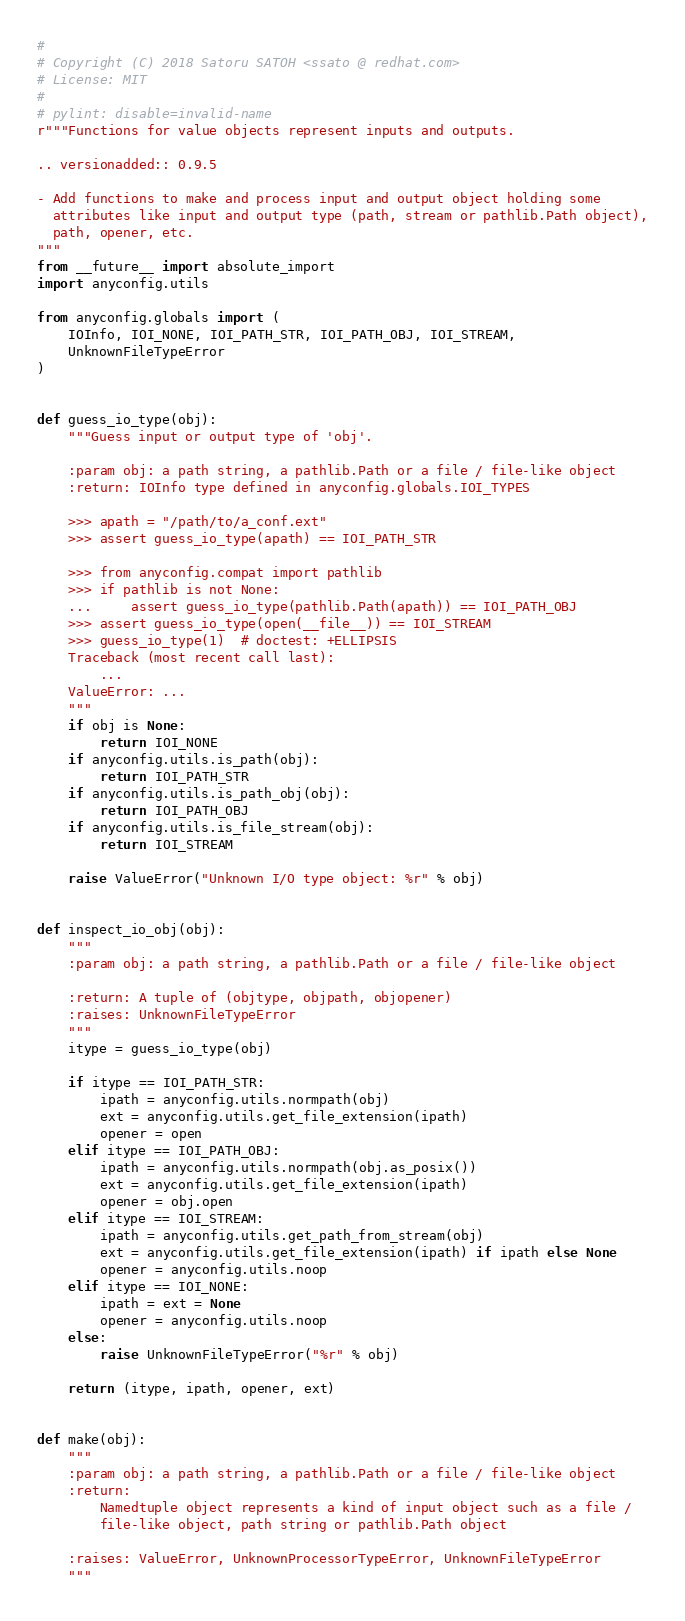<code> <loc_0><loc_0><loc_500><loc_500><_Python_>#
# Copyright (C) 2018 Satoru SATOH <ssato @ redhat.com>
# License: MIT
#
# pylint: disable=invalid-name
r"""Functions for value objects represent inputs and outputs.

.. versionadded:: 0.9.5

- Add functions to make and process input and output object holding some
  attributes like input and output type (path, stream or pathlib.Path object),
  path, opener, etc.
"""
from __future__ import absolute_import
import anyconfig.utils

from anyconfig.globals import (
    IOInfo, IOI_NONE, IOI_PATH_STR, IOI_PATH_OBJ, IOI_STREAM,
    UnknownFileTypeError
)


def guess_io_type(obj):
    """Guess input or output type of 'obj'.

    :param obj: a path string, a pathlib.Path or a file / file-like object
    :return: IOInfo type defined in anyconfig.globals.IOI_TYPES

    >>> apath = "/path/to/a_conf.ext"
    >>> assert guess_io_type(apath) == IOI_PATH_STR

    >>> from anyconfig.compat import pathlib
    >>> if pathlib is not None:
    ...     assert guess_io_type(pathlib.Path(apath)) == IOI_PATH_OBJ
    >>> assert guess_io_type(open(__file__)) == IOI_STREAM
    >>> guess_io_type(1)  # doctest: +ELLIPSIS
    Traceback (most recent call last):
        ...
    ValueError: ...
    """
    if obj is None:
        return IOI_NONE
    if anyconfig.utils.is_path(obj):
        return IOI_PATH_STR
    if anyconfig.utils.is_path_obj(obj):
        return IOI_PATH_OBJ
    if anyconfig.utils.is_file_stream(obj):
        return IOI_STREAM

    raise ValueError("Unknown I/O type object: %r" % obj)


def inspect_io_obj(obj):
    """
    :param obj: a path string, a pathlib.Path or a file / file-like object

    :return: A tuple of (objtype, objpath, objopener)
    :raises: UnknownFileTypeError
    """
    itype = guess_io_type(obj)

    if itype == IOI_PATH_STR:
        ipath = anyconfig.utils.normpath(obj)
        ext = anyconfig.utils.get_file_extension(ipath)
        opener = open
    elif itype == IOI_PATH_OBJ:
        ipath = anyconfig.utils.normpath(obj.as_posix())
        ext = anyconfig.utils.get_file_extension(ipath)
        opener = obj.open
    elif itype == IOI_STREAM:
        ipath = anyconfig.utils.get_path_from_stream(obj)
        ext = anyconfig.utils.get_file_extension(ipath) if ipath else None
        opener = anyconfig.utils.noop
    elif itype == IOI_NONE:
        ipath = ext = None
        opener = anyconfig.utils.noop
    else:
        raise UnknownFileTypeError("%r" % obj)

    return (itype, ipath, opener, ext)


def make(obj):
    """
    :param obj: a path string, a pathlib.Path or a file / file-like object
    :return:
        Namedtuple object represents a kind of input object such as a file /
        file-like object, path string or pathlib.Path object

    :raises: ValueError, UnknownProcessorTypeError, UnknownFileTypeError
    """</code> 